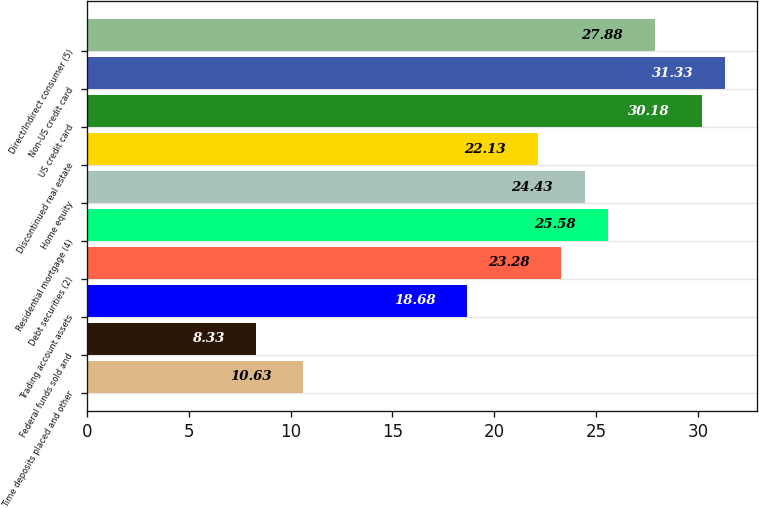<chart> <loc_0><loc_0><loc_500><loc_500><bar_chart><fcel>Time deposits placed and other<fcel>Federal funds sold and<fcel>Trading account assets<fcel>Debt securities (2)<fcel>Residential mortgage (4)<fcel>Home equity<fcel>Discontinued real estate<fcel>US credit card<fcel>Non-US credit card<fcel>Direct/Indirect consumer (5)<nl><fcel>10.63<fcel>8.33<fcel>18.68<fcel>23.28<fcel>25.58<fcel>24.43<fcel>22.13<fcel>30.18<fcel>31.33<fcel>27.88<nl></chart> 